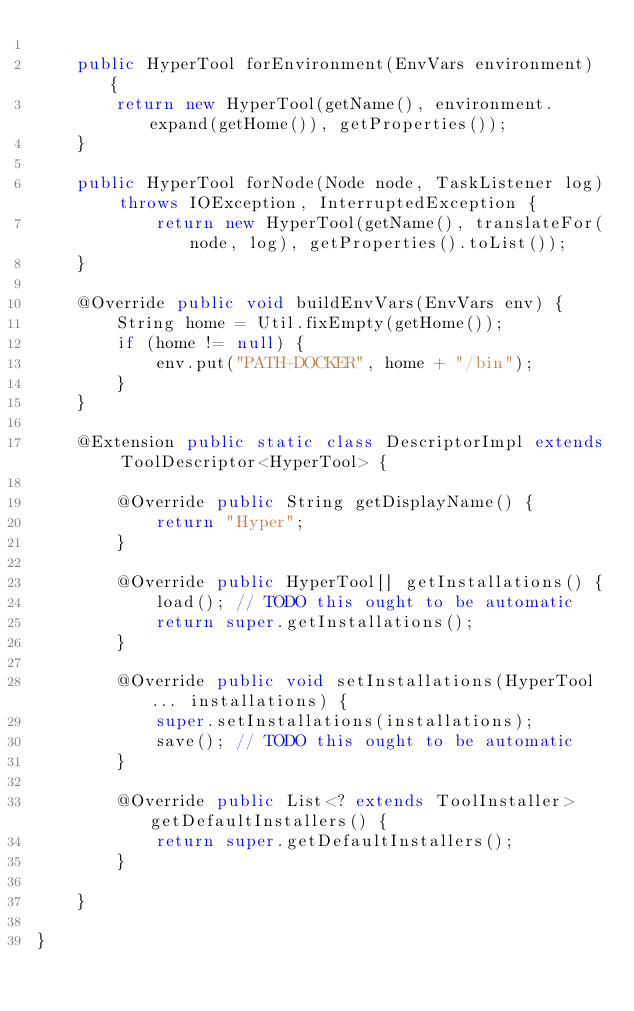Convert code to text. <code><loc_0><loc_0><loc_500><loc_500><_Java_>
    public HyperTool forEnvironment(EnvVars environment) {
        return new HyperTool(getName(), environment.expand(getHome()), getProperties());
    }

    public HyperTool forNode(Node node, TaskListener log) throws IOException, InterruptedException {
            return new HyperTool(getName(), translateFor(node, log), getProperties().toList());
    }

    @Override public void buildEnvVars(EnvVars env) {
        String home = Util.fixEmpty(getHome());
        if (home != null) {
            env.put("PATH+DOCKER", home + "/bin");
        }
    }

    @Extension public static class DescriptorImpl extends ToolDescriptor<HyperTool> {

        @Override public String getDisplayName() {
            return "Hyper";
        }

        @Override public HyperTool[] getInstallations() {
            load(); // TODO this ought to be automatic
            return super.getInstallations();
        }

        @Override public void setInstallations(HyperTool... installations) {
            super.setInstallations(installations);
            save(); // TODO this ought to be automatic
        }

        @Override public List<? extends ToolInstaller> getDefaultInstallers() {
            return super.getDefaultInstallers();
        }

    }

}
</code> 